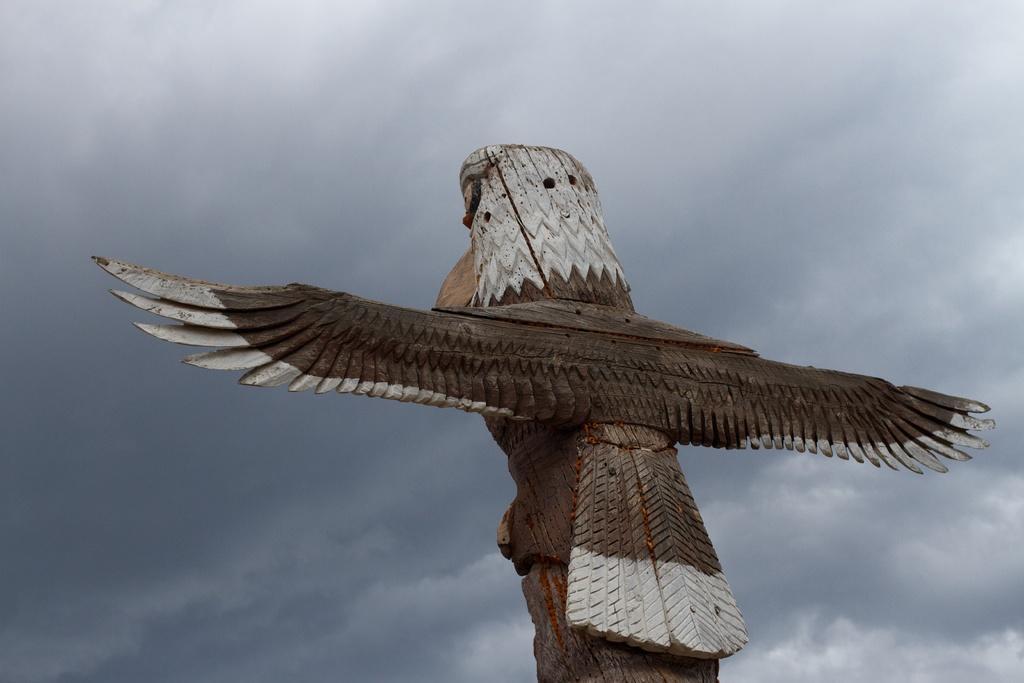Can you describe this image briefly? This is a carving of a bird on a wood. In the background there is sky with clouds. 